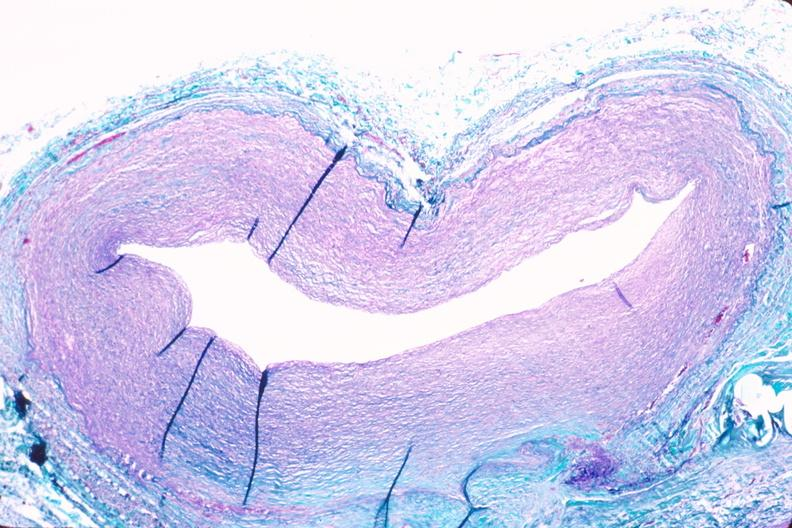what is present?
Answer the question using a single word or phrase. Cardiovascular 